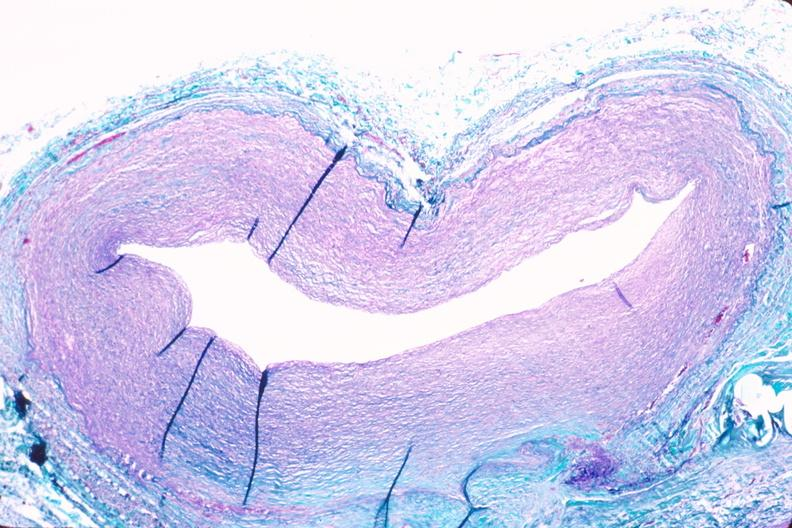what is present?
Answer the question using a single word or phrase. Cardiovascular 